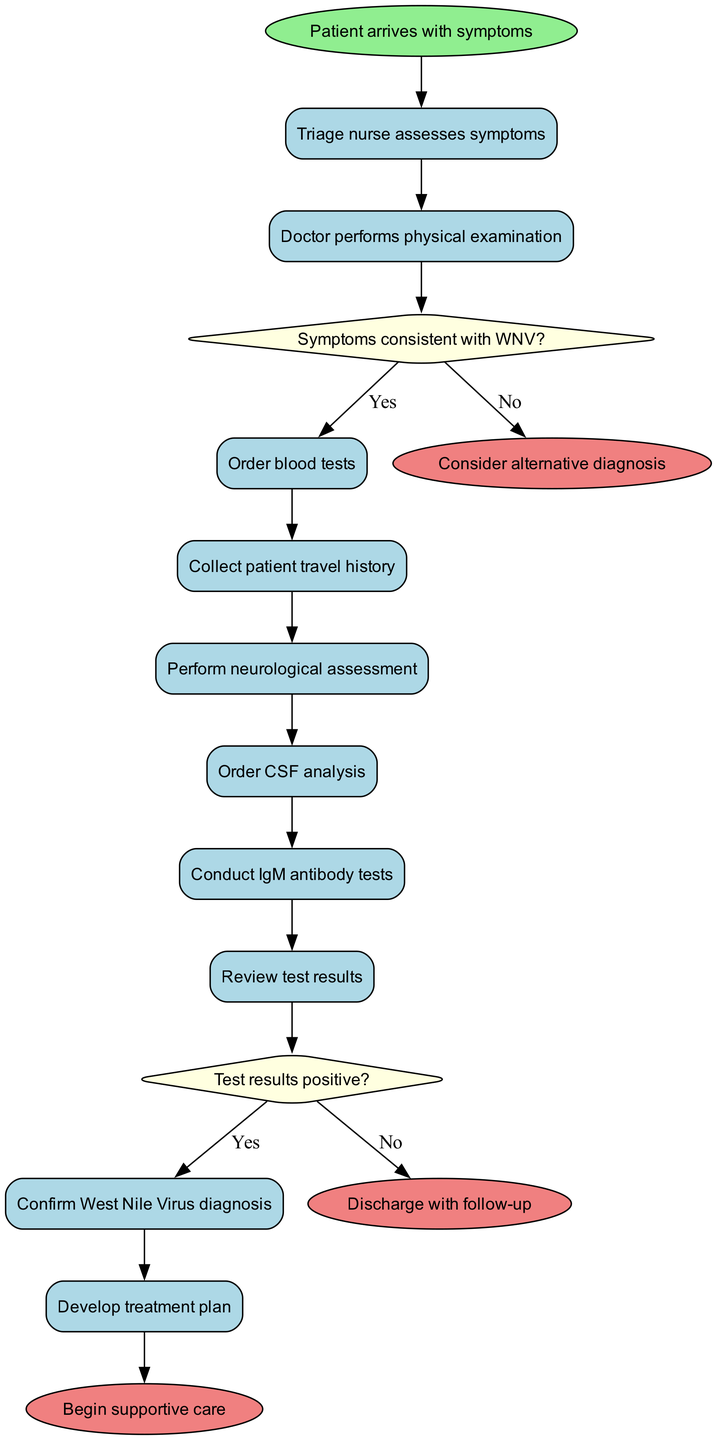What is the starting point of the diagram? The starting point of the diagram is labeled as "Patient arrives with symptoms". This is the first node and indicates where the process begins.
Answer: Patient arrives with symptoms How many activities are included in the diagram? By counting the activities listed, we see there are a total of 9 activities depicted in the diagram that the patient goes through after admission.
Answer: 9 What does the decision node 'Symptoms consistent with WNV?' lead to if the answer is 'No'? According to the flow of the diagram, if the answer to the question "Symptoms consistent with WNV?" is 'No', then it leads directly to the end node labeled "Consider alternative diagnosis".
Answer: Consider alternative diagnosis What happens after 'Order CSF analysis'? Following the activity named 'Order CSF analysis', the diagram indicates that the next activity is 'Conduct IgM antibody tests', which means that these tests are performed in sequence after collecting CSF analysis.
Answer: Conduct IgM antibody tests How many end nodes are depicted in the diagram? The diagram shows a total of 3 end nodes, which represent the different possible outcomes of the diagnostic process in the activity diagram.
Answer: 3 What is the activity that occurs just before developing the treatment plan? The activity that precedes 'Develop treatment plan' in the diagram is 'Confirm West Nile Virus diagnosis'. This confirms the diagnosis before proceeding to plan treatment.
Answer: Confirm West Nile Virus diagnosis What are the outcomes if the test results are 'Yes'? If the test results are 'Yes', the flow of the diagram indicates that this leads to the 'Confirm West Nile Virus diagnosis', following which the treatment plan can be developed.
Answer: Confirm West Nile Virus diagnosis What is the result of the final activity in the diagram? The final activity in the diagram is 'Develop treatment plan', which concludes with the action being taken to initiate patient care based on the diagnosis made earlier.
Answer: Begin supportive care 